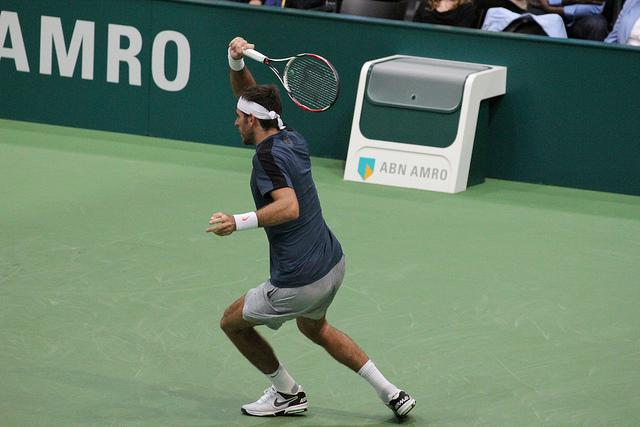What bank is a sponsor of the tennis event?

Choices:
A) chase
B) wells fargo
C) citibank
D) abn amro abn amro 